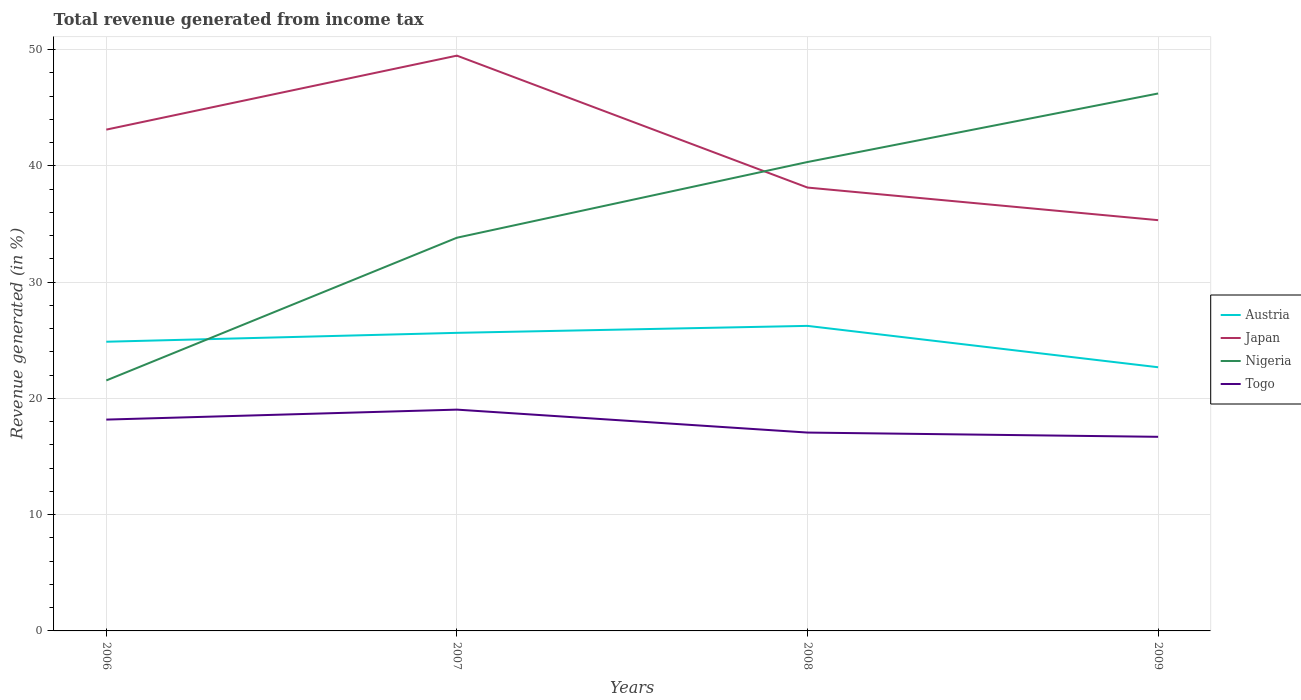Across all years, what is the maximum total revenue generated in Nigeria?
Your answer should be very brief. 21.55. What is the total total revenue generated in Nigeria in the graph?
Your answer should be very brief. -18.79. What is the difference between the highest and the second highest total revenue generated in Austria?
Ensure brevity in your answer.  3.56. What is the difference between the highest and the lowest total revenue generated in Togo?
Give a very brief answer. 2. Is the total revenue generated in Austria strictly greater than the total revenue generated in Togo over the years?
Provide a succinct answer. No. How many lines are there?
Offer a very short reply. 4. What is the difference between two consecutive major ticks on the Y-axis?
Keep it short and to the point. 10. Are the values on the major ticks of Y-axis written in scientific E-notation?
Offer a terse response. No. Does the graph contain any zero values?
Your response must be concise. No. Does the graph contain grids?
Your answer should be very brief. Yes. How are the legend labels stacked?
Offer a terse response. Vertical. What is the title of the graph?
Offer a very short reply. Total revenue generated from income tax. What is the label or title of the X-axis?
Your response must be concise. Years. What is the label or title of the Y-axis?
Your response must be concise. Revenue generated (in %). What is the Revenue generated (in %) of Austria in 2006?
Give a very brief answer. 24.88. What is the Revenue generated (in %) of Japan in 2006?
Offer a very short reply. 43.12. What is the Revenue generated (in %) in Nigeria in 2006?
Ensure brevity in your answer.  21.55. What is the Revenue generated (in %) in Togo in 2006?
Give a very brief answer. 18.18. What is the Revenue generated (in %) of Austria in 2007?
Your response must be concise. 25.64. What is the Revenue generated (in %) of Japan in 2007?
Your answer should be compact. 49.49. What is the Revenue generated (in %) of Nigeria in 2007?
Ensure brevity in your answer.  33.83. What is the Revenue generated (in %) in Togo in 2007?
Provide a short and direct response. 19.04. What is the Revenue generated (in %) of Austria in 2008?
Keep it short and to the point. 26.24. What is the Revenue generated (in %) in Japan in 2008?
Ensure brevity in your answer.  38.14. What is the Revenue generated (in %) of Nigeria in 2008?
Your response must be concise. 40.34. What is the Revenue generated (in %) of Togo in 2008?
Offer a very short reply. 17.06. What is the Revenue generated (in %) in Austria in 2009?
Offer a very short reply. 22.68. What is the Revenue generated (in %) of Japan in 2009?
Your answer should be very brief. 35.34. What is the Revenue generated (in %) in Nigeria in 2009?
Make the answer very short. 46.23. What is the Revenue generated (in %) in Togo in 2009?
Make the answer very short. 16.7. Across all years, what is the maximum Revenue generated (in %) of Austria?
Keep it short and to the point. 26.24. Across all years, what is the maximum Revenue generated (in %) of Japan?
Your response must be concise. 49.49. Across all years, what is the maximum Revenue generated (in %) in Nigeria?
Provide a short and direct response. 46.23. Across all years, what is the maximum Revenue generated (in %) in Togo?
Keep it short and to the point. 19.04. Across all years, what is the minimum Revenue generated (in %) of Austria?
Your answer should be very brief. 22.68. Across all years, what is the minimum Revenue generated (in %) in Japan?
Give a very brief answer. 35.34. Across all years, what is the minimum Revenue generated (in %) in Nigeria?
Give a very brief answer. 21.55. Across all years, what is the minimum Revenue generated (in %) in Togo?
Provide a short and direct response. 16.7. What is the total Revenue generated (in %) of Austria in the graph?
Your answer should be very brief. 99.44. What is the total Revenue generated (in %) of Japan in the graph?
Offer a terse response. 166.09. What is the total Revenue generated (in %) in Nigeria in the graph?
Your answer should be very brief. 141.95. What is the total Revenue generated (in %) of Togo in the graph?
Offer a very short reply. 70.98. What is the difference between the Revenue generated (in %) in Austria in 2006 and that in 2007?
Offer a very short reply. -0.77. What is the difference between the Revenue generated (in %) in Japan in 2006 and that in 2007?
Your answer should be compact. -6.37. What is the difference between the Revenue generated (in %) in Nigeria in 2006 and that in 2007?
Make the answer very short. -12.28. What is the difference between the Revenue generated (in %) in Togo in 2006 and that in 2007?
Give a very brief answer. -0.86. What is the difference between the Revenue generated (in %) of Austria in 2006 and that in 2008?
Your answer should be compact. -1.36. What is the difference between the Revenue generated (in %) in Japan in 2006 and that in 2008?
Ensure brevity in your answer.  4.98. What is the difference between the Revenue generated (in %) of Nigeria in 2006 and that in 2008?
Provide a succinct answer. -18.79. What is the difference between the Revenue generated (in %) in Togo in 2006 and that in 2008?
Ensure brevity in your answer.  1.12. What is the difference between the Revenue generated (in %) of Austria in 2006 and that in 2009?
Offer a very short reply. 2.19. What is the difference between the Revenue generated (in %) of Japan in 2006 and that in 2009?
Give a very brief answer. 7.79. What is the difference between the Revenue generated (in %) of Nigeria in 2006 and that in 2009?
Your answer should be compact. -24.69. What is the difference between the Revenue generated (in %) in Togo in 2006 and that in 2009?
Provide a short and direct response. 1.48. What is the difference between the Revenue generated (in %) of Austria in 2007 and that in 2008?
Offer a very short reply. -0.6. What is the difference between the Revenue generated (in %) in Japan in 2007 and that in 2008?
Ensure brevity in your answer.  11.35. What is the difference between the Revenue generated (in %) of Nigeria in 2007 and that in 2008?
Offer a very short reply. -6.51. What is the difference between the Revenue generated (in %) in Togo in 2007 and that in 2008?
Keep it short and to the point. 1.97. What is the difference between the Revenue generated (in %) in Austria in 2007 and that in 2009?
Give a very brief answer. 2.96. What is the difference between the Revenue generated (in %) of Japan in 2007 and that in 2009?
Make the answer very short. 14.15. What is the difference between the Revenue generated (in %) of Nigeria in 2007 and that in 2009?
Keep it short and to the point. -12.41. What is the difference between the Revenue generated (in %) in Togo in 2007 and that in 2009?
Your answer should be very brief. 2.34. What is the difference between the Revenue generated (in %) of Austria in 2008 and that in 2009?
Keep it short and to the point. 3.56. What is the difference between the Revenue generated (in %) of Japan in 2008 and that in 2009?
Keep it short and to the point. 2.8. What is the difference between the Revenue generated (in %) of Nigeria in 2008 and that in 2009?
Provide a short and direct response. -5.9. What is the difference between the Revenue generated (in %) of Togo in 2008 and that in 2009?
Ensure brevity in your answer.  0.37. What is the difference between the Revenue generated (in %) of Austria in 2006 and the Revenue generated (in %) of Japan in 2007?
Provide a short and direct response. -24.61. What is the difference between the Revenue generated (in %) in Austria in 2006 and the Revenue generated (in %) in Nigeria in 2007?
Your answer should be compact. -8.95. What is the difference between the Revenue generated (in %) in Austria in 2006 and the Revenue generated (in %) in Togo in 2007?
Offer a terse response. 5.84. What is the difference between the Revenue generated (in %) of Japan in 2006 and the Revenue generated (in %) of Nigeria in 2007?
Ensure brevity in your answer.  9.3. What is the difference between the Revenue generated (in %) in Japan in 2006 and the Revenue generated (in %) in Togo in 2007?
Offer a terse response. 24.09. What is the difference between the Revenue generated (in %) of Nigeria in 2006 and the Revenue generated (in %) of Togo in 2007?
Give a very brief answer. 2.51. What is the difference between the Revenue generated (in %) of Austria in 2006 and the Revenue generated (in %) of Japan in 2008?
Make the answer very short. -13.26. What is the difference between the Revenue generated (in %) in Austria in 2006 and the Revenue generated (in %) in Nigeria in 2008?
Your answer should be compact. -15.46. What is the difference between the Revenue generated (in %) of Austria in 2006 and the Revenue generated (in %) of Togo in 2008?
Your answer should be very brief. 7.81. What is the difference between the Revenue generated (in %) of Japan in 2006 and the Revenue generated (in %) of Nigeria in 2008?
Your answer should be very brief. 2.79. What is the difference between the Revenue generated (in %) in Japan in 2006 and the Revenue generated (in %) in Togo in 2008?
Your answer should be compact. 26.06. What is the difference between the Revenue generated (in %) in Nigeria in 2006 and the Revenue generated (in %) in Togo in 2008?
Give a very brief answer. 4.48. What is the difference between the Revenue generated (in %) in Austria in 2006 and the Revenue generated (in %) in Japan in 2009?
Provide a succinct answer. -10.46. What is the difference between the Revenue generated (in %) in Austria in 2006 and the Revenue generated (in %) in Nigeria in 2009?
Your answer should be compact. -21.36. What is the difference between the Revenue generated (in %) of Austria in 2006 and the Revenue generated (in %) of Togo in 2009?
Offer a very short reply. 8.18. What is the difference between the Revenue generated (in %) of Japan in 2006 and the Revenue generated (in %) of Nigeria in 2009?
Your response must be concise. -3.11. What is the difference between the Revenue generated (in %) in Japan in 2006 and the Revenue generated (in %) in Togo in 2009?
Give a very brief answer. 26.43. What is the difference between the Revenue generated (in %) of Nigeria in 2006 and the Revenue generated (in %) of Togo in 2009?
Offer a very short reply. 4.85. What is the difference between the Revenue generated (in %) in Austria in 2007 and the Revenue generated (in %) in Japan in 2008?
Your response must be concise. -12.5. What is the difference between the Revenue generated (in %) in Austria in 2007 and the Revenue generated (in %) in Nigeria in 2008?
Provide a succinct answer. -14.7. What is the difference between the Revenue generated (in %) in Austria in 2007 and the Revenue generated (in %) in Togo in 2008?
Make the answer very short. 8.58. What is the difference between the Revenue generated (in %) of Japan in 2007 and the Revenue generated (in %) of Nigeria in 2008?
Offer a terse response. 9.15. What is the difference between the Revenue generated (in %) in Japan in 2007 and the Revenue generated (in %) in Togo in 2008?
Your answer should be very brief. 32.43. What is the difference between the Revenue generated (in %) of Nigeria in 2007 and the Revenue generated (in %) of Togo in 2008?
Your answer should be compact. 16.76. What is the difference between the Revenue generated (in %) in Austria in 2007 and the Revenue generated (in %) in Japan in 2009?
Your response must be concise. -9.69. What is the difference between the Revenue generated (in %) in Austria in 2007 and the Revenue generated (in %) in Nigeria in 2009?
Offer a very short reply. -20.59. What is the difference between the Revenue generated (in %) of Austria in 2007 and the Revenue generated (in %) of Togo in 2009?
Make the answer very short. 8.94. What is the difference between the Revenue generated (in %) of Japan in 2007 and the Revenue generated (in %) of Nigeria in 2009?
Make the answer very short. 3.26. What is the difference between the Revenue generated (in %) of Japan in 2007 and the Revenue generated (in %) of Togo in 2009?
Provide a succinct answer. 32.79. What is the difference between the Revenue generated (in %) in Nigeria in 2007 and the Revenue generated (in %) in Togo in 2009?
Provide a short and direct response. 17.13. What is the difference between the Revenue generated (in %) of Austria in 2008 and the Revenue generated (in %) of Japan in 2009?
Provide a succinct answer. -9.09. What is the difference between the Revenue generated (in %) of Austria in 2008 and the Revenue generated (in %) of Nigeria in 2009?
Ensure brevity in your answer.  -19.99. What is the difference between the Revenue generated (in %) of Austria in 2008 and the Revenue generated (in %) of Togo in 2009?
Provide a succinct answer. 9.54. What is the difference between the Revenue generated (in %) of Japan in 2008 and the Revenue generated (in %) of Nigeria in 2009?
Your answer should be compact. -8.09. What is the difference between the Revenue generated (in %) in Japan in 2008 and the Revenue generated (in %) in Togo in 2009?
Make the answer very short. 21.44. What is the difference between the Revenue generated (in %) of Nigeria in 2008 and the Revenue generated (in %) of Togo in 2009?
Your answer should be very brief. 23.64. What is the average Revenue generated (in %) of Austria per year?
Your answer should be compact. 24.86. What is the average Revenue generated (in %) in Japan per year?
Provide a succinct answer. 41.52. What is the average Revenue generated (in %) in Nigeria per year?
Ensure brevity in your answer.  35.49. What is the average Revenue generated (in %) in Togo per year?
Provide a succinct answer. 17.74. In the year 2006, what is the difference between the Revenue generated (in %) in Austria and Revenue generated (in %) in Japan?
Keep it short and to the point. -18.25. In the year 2006, what is the difference between the Revenue generated (in %) in Austria and Revenue generated (in %) in Nigeria?
Provide a succinct answer. 3.33. In the year 2006, what is the difference between the Revenue generated (in %) in Austria and Revenue generated (in %) in Togo?
Give a very brief answer. 6.7. In the year 2006, what is the difference between the Revenue generated (in %) in Japan and Revenue generated (in %) in Nigeria?
Provide a short and direct response. 21.58. In the year 2006, what is the difference between the Revenue generated (in %) in Japan and Revenue generated (in %) in Togo?
Offer a very short reply. 24.94. In the year 2006, what is the difference between the Revenue generated (in %) of Nigeria and Revenue generated (in %) of Togo?
Your answer should be compact. 3.37. In the year 2007, what is the difference between the Revenue generated (in %) in Austria and Revenue generated (in %) in Japan?
Provide a succinct answer. -23.85. In the year 2007, what is the difference between the Revenue generated (in %) of Austria and Revenue generated (in %) of Nigeria?
Offer a terse response. -8.18. In the year 2007, what is the difference between the Revenue generated (in %) of Austria and Revenue generated (in %) of Togo?
Provide a short and direct response. 6.61. In the year 2007, what is the difference between the Revenue generated (in %) in Japan and Revenue generated (in %) in Nigeria?
Provide a short and direct response. 15.66. In the year 2007, what is the difference between the Revenue generated (in %) in Japan and Revenue generated (in %) in Togo?
Offer a terse response. 30.45. In the year 2007, what is the difference between the Revenue generated (in %) in Nigeria and Revenue generated (in %) in Togo?
Offer a terse response. 14.79. In the year 2008, what is the difference between the Revenue generated (in %) of Austria and Revenue generated (in %) of Japan?
Ensure brevity in your answer.  -11.9. In the year 2008, what is the difference between the Revenue generated (in %) in Austria and Revenue generated (in %) in Nigeria?
Keep it short and to the point. -14.1. In the year 2008, what is the difference between the Revenue generated (in %) in Austria and Revenue generated (in %) in Togo?
Give a very brief answer. 9.18. In the year 2008, what is the difference between the Revenue generated (in %) in Japan and Revenue generated (in %) in Nigeria?
Give a very brief answer. -2.2. In the year 2008, what is the difference between the Revenue generated (in %) in Japan and Revenue generated (in %) in Togo?
Make the answer very short. 21.08. In the year 2008, what is the difference between the Revenue generated (in %) of Nigeria and Revenue generated (in %) of Togo?
Ensure brevity in your answer.  23.27. In the year 2009, what is the difference between the Revenue generated (in %) of Austria and Revenue generated (in %) of Japan?
Offer a very short reply. -12.65. In the year 2009, what is the difference between the Revenue generated (in %) in Austria and Revenue generated (in %) in Nigeria?
Your answer should be very brief. -23.55. In the year 2009, what is the difference between the Revenue generated (in %) of Austria and Revenue generated (in %) of Togo?
Make the answer very short. 5.99. In the year 2009, what is the difference between the Revenue generated (in %) of Japan and Revenue generated (in %) of Nigeria?
Provide a short and direct response. -10.9. In the year 2009, what is the difference between the Revenue generated (in %) of Japan and Revenue generated (in %) of Togo?
Your answer should be very brief. 18.64. In the year 2009, what is the difference between the Revenue generated (in %) in Nigeria and Revenue generated (in %) in Togo?
Keep it short and to the point. 29.54. What is the ratio of the Revenue generated (in %) in Austria in 2006 to that in 2007?
Keep it short and to the point. 0.97. What is the ratio of the Revenue generated (in %) of Japan in 2006 to that in 2007?
Provide a short and direct response. 0.87. What is the ratio of the Revenue generated (in %) of Nigeria in 2006 to that in 2007?
Your response must be concise. 0.64. What is the ratio of the Revenue generated (in %) in Togo in 2006 to that in 2007?
Give a very brief answer. 0.95. What is the ratio of the Revenue generated (in %) of Austria in 2006 to that in 2008?
Make the answer very short. 0.95. What is the ratio of the Revenue generated (in %) in Japan in 2006 to that in 2008?
Your answer should be very brief. 1.13. What is the ratio of the Revenue generated (in %) of Nigeria in 2006 to that in 2008?
Your answer should be very brief. 0.53. What is the ratio of the Revenue generated (in %) in Togo in 2006 to that in 2008?
Your answer should be compact. 1.07. What is the ratio of the Revenue generated (in %) in Austria in 2006 to that in 2009?
Offer a terse response. 1.1. What is the ratio of the Revenue generated (in %) of Japan in 2006 to that in 2009?
Give a very brief answer. 1.22. What is the ratio of the Revenue generated (in %) in Nigeria in 2006 to that in 2009?
Make the answer very short. 0.47. What is the ratio of the Revenue generated (in %) of Togo in 2006 to that in 2009?
Offer a terse response. 1.09. What is the ratio of the Revenue generated (in %) in Austria in 2007 to that in 2008?
Make the answer very short. 0.98. What is the ratio of the Revenue generated (in %) in Japan in 2007 to that in 2008?
Offer a terse response. 1.3. What is the ratio of the Revenue generated (in %) in Nigeria in 2007 to that in 2008?
Keep it short and to the point. 0.84. What is the ratio of the Revenue generated (in %) in Togo in 2007 to that in 2008?
Ensure brevity in your answer.  1.12. What is the ratio of the Revenue generated (in %) in Austria in 2007 to that in 2009?
Your response must be concise. 1.13. What is the ratio of the Revenue generated (in %) of Japan in 2007 to that in 2009?
Offer a terse response. 1.4. What is the ratio of the Revenue generated (in %) in Nigeria in 2007 to that in 2009?
Give a very brief answer. 0.73. What is the ratio of the Revenue generated (in %) in Togo in 2007 to that in 2009?
Make the answer very short. 1.14. What is the ratio of the Revenue generated (in %) of Austria in 2008 to that in 2009?
Offer a very short reply. 1.16. What is the ratio of the Revenue generated (in %) of Japan in 2008 to that in 2009?
Give a very brief answer. 1.08. What is the ratio of the Revenue generated (in %) in Nigeria in 2008 to that in 2009?
Offer a very short reply. 0.87. What is the ratio of the Revenue generated (in %) in Togo in 2008 to that in 2009?
Give a very brief answer. 1.02. What is the difference between the highest and the second highest Revenue generated (in %) in Austria?
Provide a short and direct response. 0.6. What is the difference between the highest and the second highest Revenue generated (in %) of Japan?
Your answer should be very brief. 6.37. What is the difference between the highest and the second highest Revenue generated (in %) of Nigeria?
Offer a terse response. 5.9. What is the difference between the highest and the second highest Revenue generated (in %) of Togo?
Make the answer very short. 0.86. What is the difference between the highest and the lowest Revenue generated (in %) of Austria?
Provide a short and direct response. 3.56. What is the difference between the highest and the lowest Revenue generated (in %) of Japan?
Offer a very short reply. 14.15. What is the difference between the highest and the lowest Revenue generated (in %) of Nigeria?
Offer a very short reply. 24.69. What is the difference between the highest and the lowest Revenue generated (in %) in Togo?
Your answer should be very brief. 2.34. 